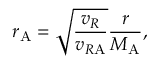Convert formula to latex. <formula><loc_0><loc_0><loc_500><loc_500>r _ { A } = \sqrt { \frac { v _ { R } } { v _ { R A } } } { \frac { r } { M _ { A } } } ,</formula> 